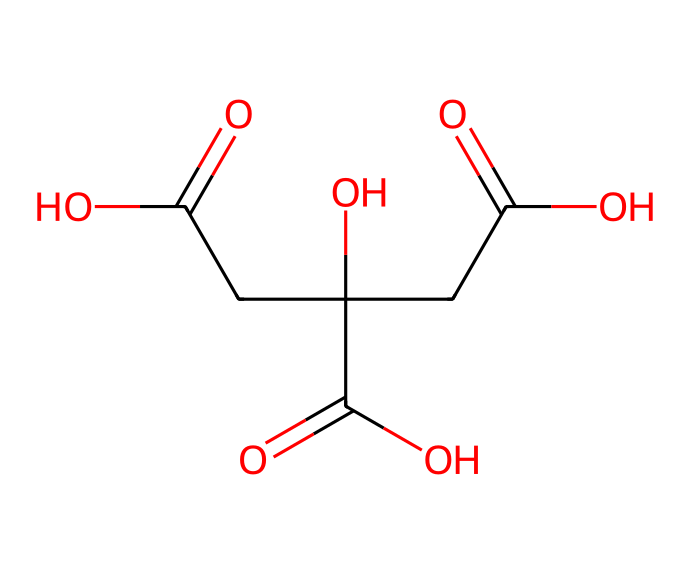What is the IUPAC name of this chemical? The SMILES representation corresponds to a compound that has multiple carboxylic acid groups, which structurally indicates that it is citric acid. Therefore, the IUPAC name is derived from its structure that contains three carboxylic acid functional groups.
Answer: citric acid How many carbon atoms are present in this structure? By analyzing the SMILES, we can count each carbon atom represented in the structure. There are six carbon atoms in the chemical structure as indicated by the presence of the 'C' in the notation.
Answer: 6 What functional groups are present in citric acid? Citric acid contains multiple functional groups. Specifically, examining the structure, we can identify three carboxylic acid groups (-COOH) based on the presence of 'C(=O)O' segments in the SMILES. These represent the functional groups that account for the acidic properties of citric acid.
Answer: carboxylic acids Is citric acid a strong or weak acid? To determine the strength of the acid, we consider that citric acid is a weak acid because it does not completely dissociate in water. Its three carboxyl groups provide weak acidity compared to strong acids, which fully dissociate.
Answer: weak What is the total number of hydrogen atoms in citric acid? In the structure represented by the SMILES, we can derive the number of hydrogen atoms by considering the bonding of carbon and oxygen atoms. Each of the three carboxylic acid groups contributes one hydrogen atom, while the remaining carbon atoms bond with enough hydrogens to satisfy the tetravalency of carbon. In total, there are eight hydrogen atoms in citric acid.
Answer: 8 How many carboxyl groups confer acidity in citric acid? By inspecting the structure based on the SMILES code, we can identify that there are three instances of the carboxyl group (-COOH). Each of these contributes to the acidity of the compound, indicating that citric acid is a tribasic acid.
Answer: 3 